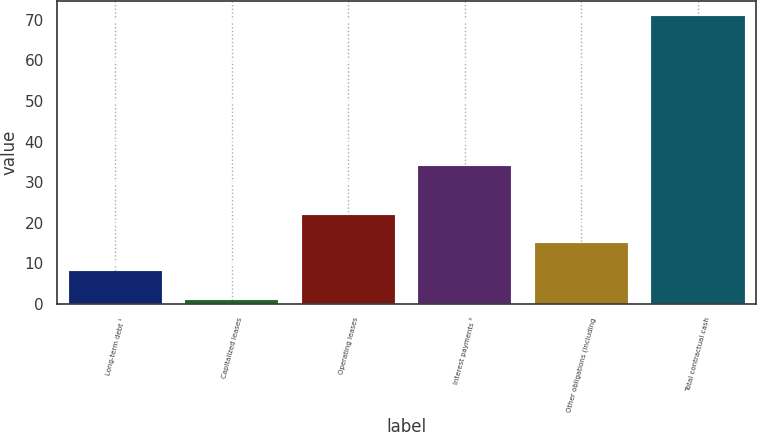<chart> <loc_0><loc_0><loc_500><loc_500><bar_chart><fcel>Long-term debt ¹<fcel>Capitalized leases<fcel>Operating leases<fcel>Interest payments ³<fcel>Other obligations (including<fcel>Total contractual cash<nl><fcel>8<fcel>1<fcel>22<fcel>34<fcel>15<fcel>71<nl></chart> 